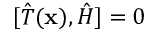<formula> <loc_0><loc_0><loc_500><loc_500>[ { \hat { T } } ( x ) , { \hat { H } } ] = 0</formula> 